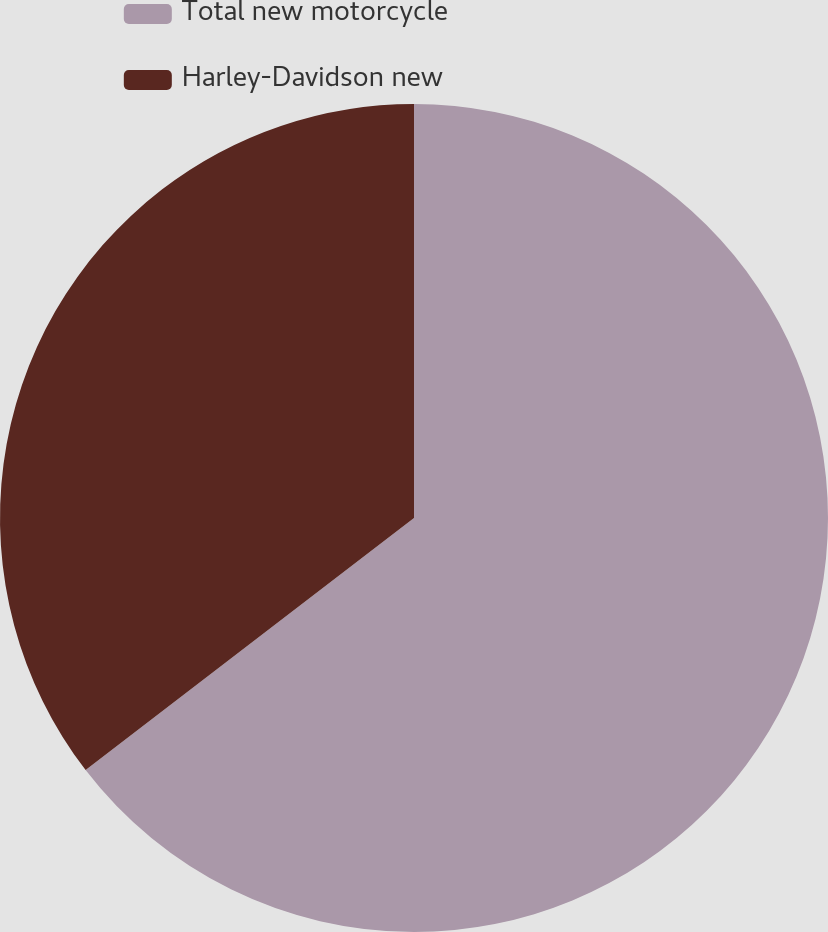Convert chart. <chart><loc_0><loc_0><loc_500><loc_500><pie_chart><fcel>Total new motorcycle<fcel>Harley-Davidson new<nl><fcel>64.58%<fcel>35.42%<nl></chart> 